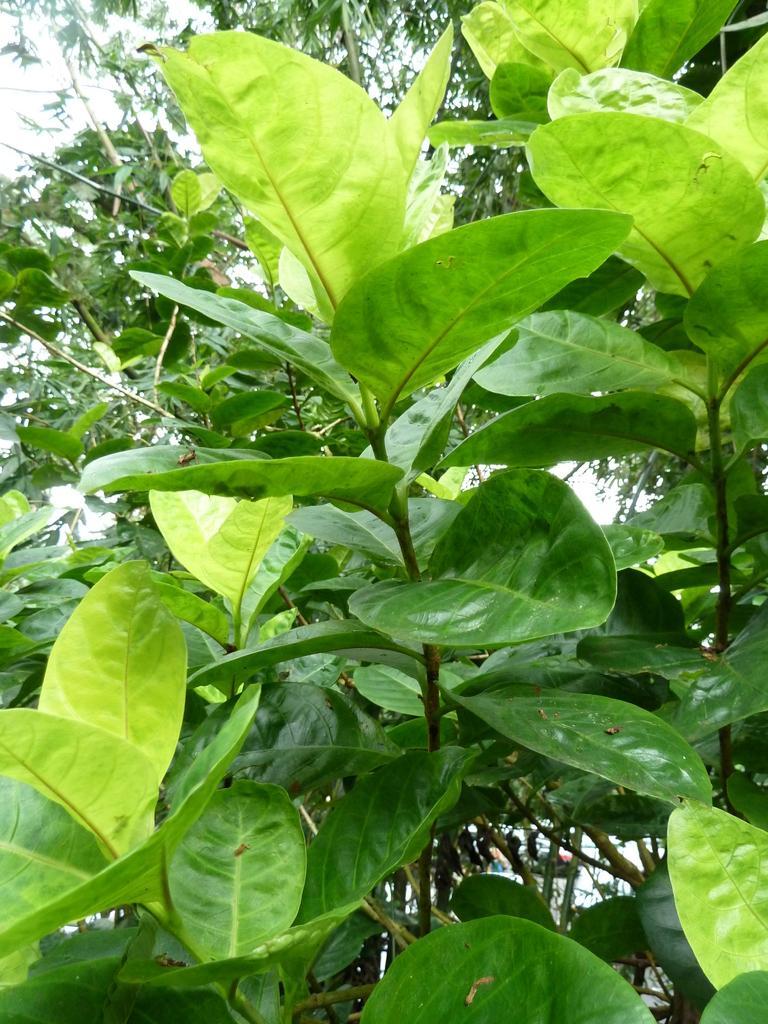Please provide a concise description of this image. We can see green leaves. In the background it is white. 